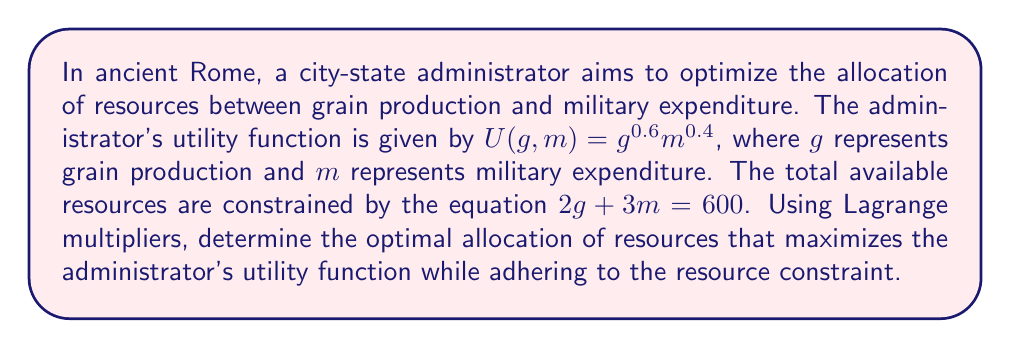What is the answer to this math problem? To solve this optimization problem using Lagrange multipliers, we follow these steps:

1. Define the Lagrangian function:
   $$L(g, m, \lambda) = g^{0.6}m^{0.4} - \lambda(2g + 3m - 600)$$

2. Calculate the partial derivatives and set them equal to zero:
   $$\frac{\partial L}{\partial g} = 0.6g^{-0.4}m^{0.4} - 2\lambda = 0$$
   $$\frac{\partial L}{\partial m} = 0.4g^{0.6}m^{-0.6} - 3\lambda = 0$$
   $$\frac{\partial L}{\partial \lambda} = 2g + 3m - 600 = 0$$

3. From the first two equations, we can establish:
   $$\frac{0.6g^{-0.4}m^{0.4}}{2} = \frac{0.4g^{0.6}m^{-0.6}}{3}$$

4. Simplify this equation:
   $$0.9g^{-0.4}m^{0.4} = 0.4g^{0.6}m^{-0.6}$$
   $$\frac{9}{4} = \frac{g}{m}$$
   $$g = \frac{9m}{4}$$

5. Substitute this into the constraint equation:
   $$2(\frac{9m}{4}) + 3m = 600$$
   $$\frac{9m}{2} + 3m = 600$$
   $$\frac{15m}{2} = 600$$
   $$m = 80$$

6. Calculate g:
   $$g = \frac{9m}{4} = \frac{9(80)}{4} = 180$$

7. Verify the constraint:
   $$2(180) + 3(80) = 360 + 240 = 600$$

Thus, the optimal allocation is 180 units for grain production and 80 units for military expenditure.
Answer: The optimal allocation is $g = 180$ units for grain production and $m = 80$ units for military expenditure. 